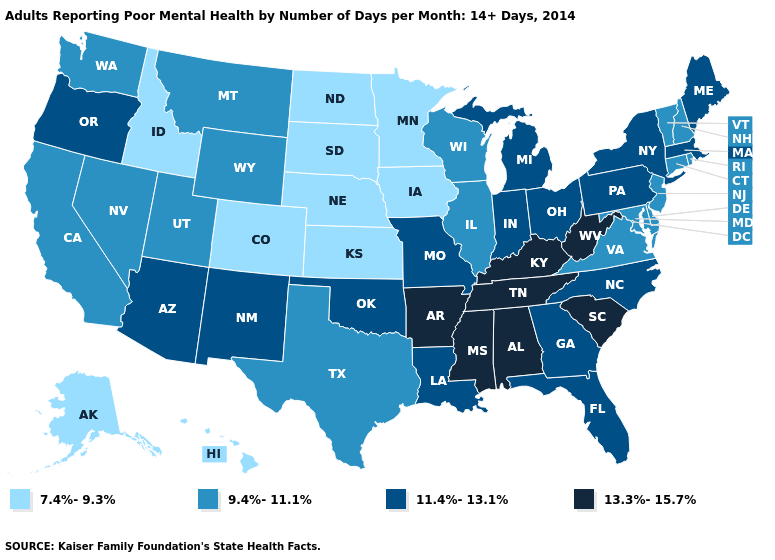Among the states that border South Carolina , which have the lowest value?
Short answer required. Georgia, North Carolina. Name the states that have a value in the range 9.4%-11.1%?
Keep it brief. California, Connecticut, Delaware, Illinois, Maryland, Montana, Nevada, New Hampshire, New Jersey, Rhode Island, Texas, Utah, Vermont, Virginia, Washington, Wisconsin, Wyoming. Does Maine have the lowest value in the Northeast?
Be succinct. No. What is the highest value in the West ?
Concise answer only. 11.4%-13.1%. Among the states that border Arizona , which have the highest value?
Short answer required. New Mexico. What is the value of Wyoming?
Short answer required. 9.4%-11.1%. How many symbols are there in the legend?
Answer briefly. 4. Is the legend a continuous bar?
Keep it brief. No. Name the states that have a value in the range 13.3%-15.7%?
Give a very brief answer. Alabama, Arkansas, Kentucky, Mississippi, South Carolina, Tennessee, West Virginia. Name the states that have a value in the range 13.3%-15.7%?
Concise answer only. Alabama, Arkansas, Kentucky, Mississippi, South Carolina, Tennessee, West Virginia. Does the map have missing data?
Write a very short answer. No. How many symbols are there in the legend?
Short answer required. 4. What is the lowest value in the West?
Keep it brief. 7.4%-9.3%. Does New York have a higher value than Texas?
Keep it brief. Yes. Which states have the lowest value in the USA?
Concise answer only. Alaska, Colorado, Hawaii, Idaho, Iowa, Kansas, Minnesota, Nebraska, North Dakota, South Dakota. 